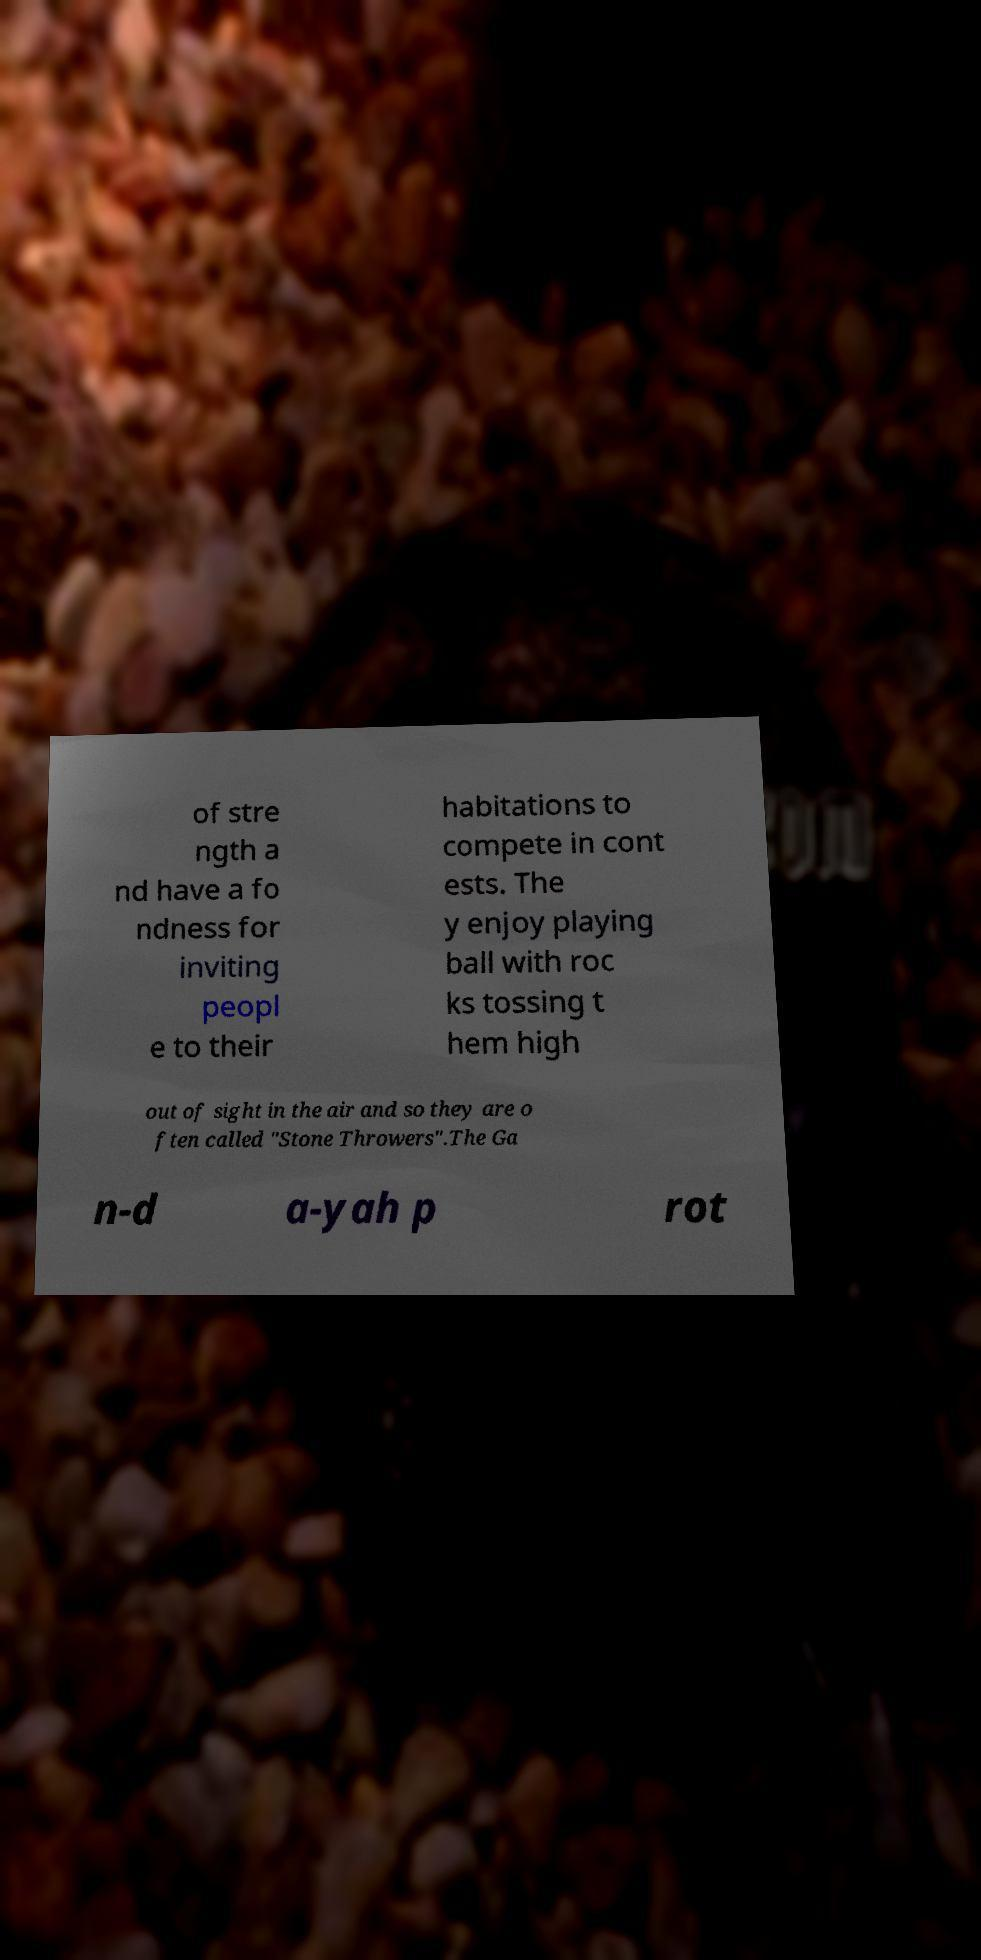Could you extract and type out the text from this image? of stre ngth a nd have a fo ndness for inviting peopl e to their habitations to compete in cont ests. The y enjoy playing ball with roc ks tossing t hem high out of sight in the air and so they are o ften called "Stone Throwers".The Ga n-d a-yah p rot 